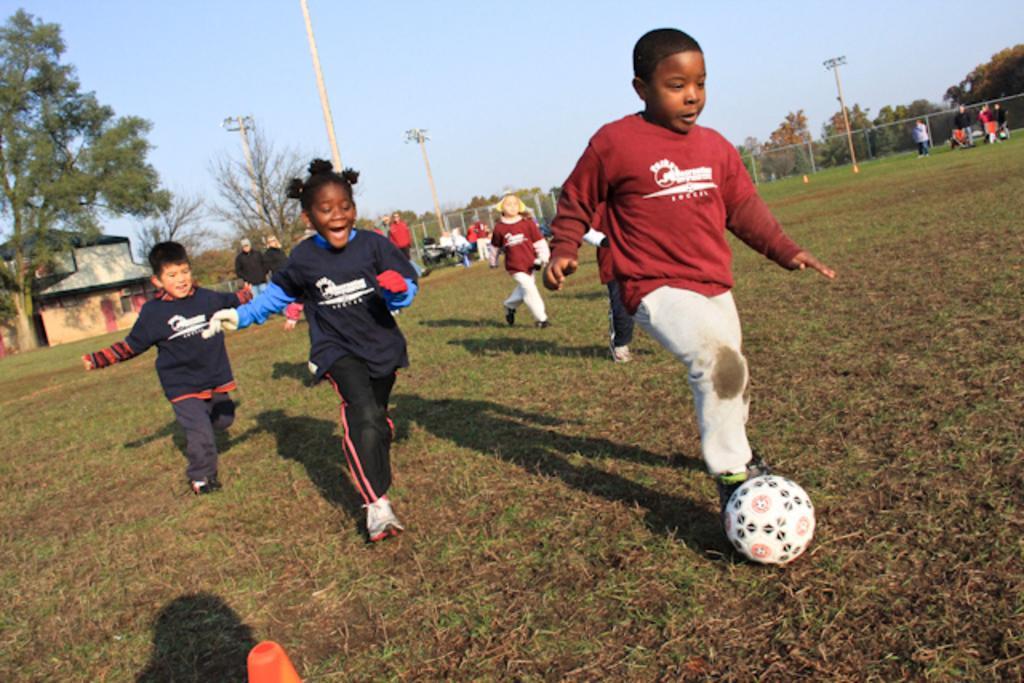Describe this image in one or two sentences. There are group of kids playing football and there are trees in the background and the ground is greenery. 